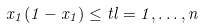Convert formula to latex. <formula><loc_0><loc_0><loc_500><loc_500>x _ { 1 } ( 1 - x _ { 1 } ) \leq t l = 1 , \dots , n</formula> 